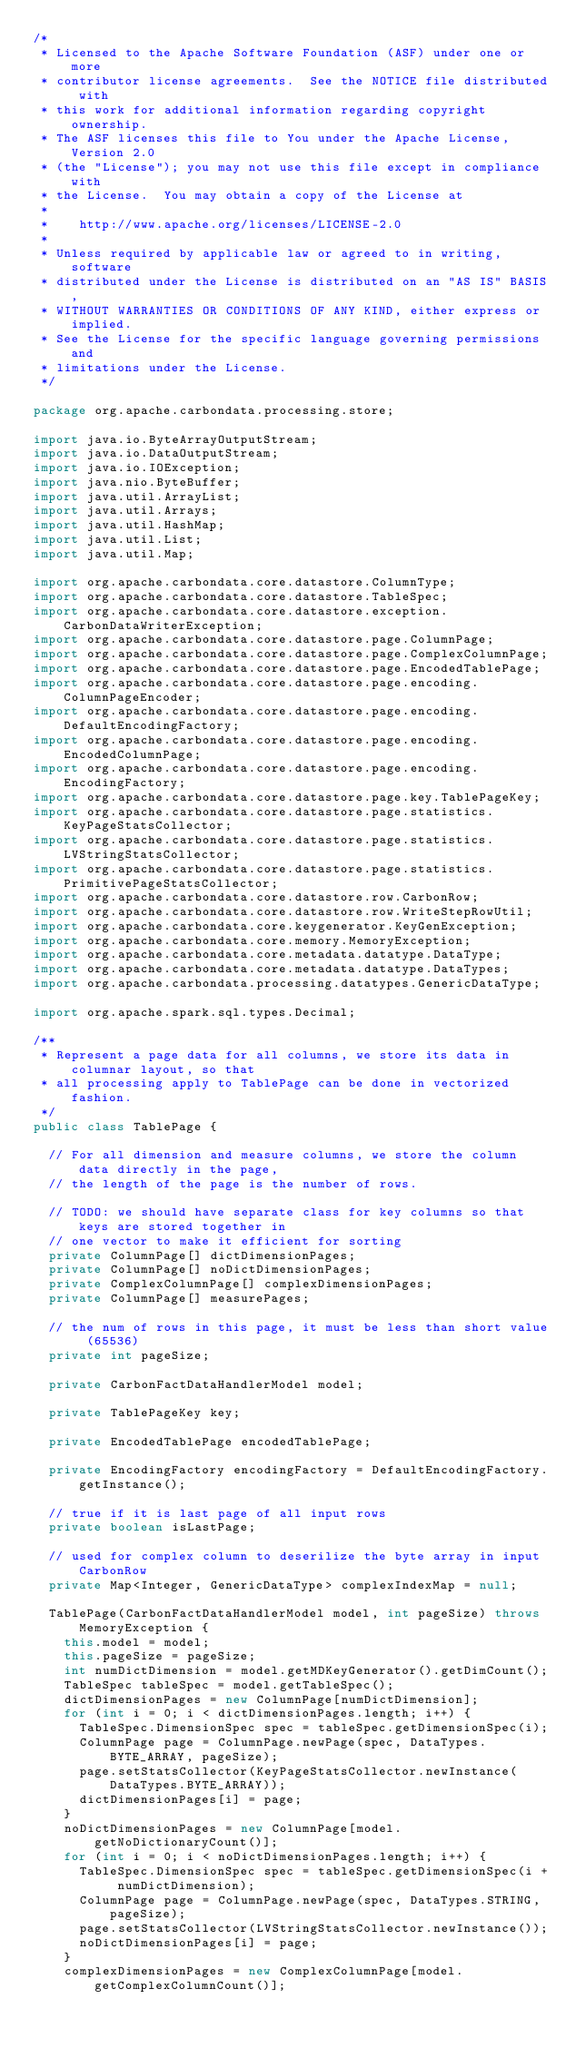<code> <loc_0><loc_0><loc_500><loc_500><_Java_>/*
 * Licensed to the Apache Software Foundation (ASF) under one or more
 * contributor license agreements.  See the NOTICE file distributed with
 * this work for additional information regarding copyright ownership.
 * The ASF licenses this file to You under the Apache License, Version 2.0
 * (the "License"); you may not use this file except in compliance with
 * the License.  You may obtain a copy of the License at
 *
 *    http://www.apache.org/licenses/LICENSE-2.0
 *
 * Unless required by applicable law or agreed to in writing, software
 * distributed under the License is distributed on an "AS IS" BASIS,
 * WITHOUT WARRANTIES OR CONDITIONS OF ANY KIND, either express or implied.
 * See the License for the specific language governing permissions and
 * limitations under the License.
 */

package org.apache.carbondata.processing.store;

import java.io.ByteArrayOutputStream;
import java.io.DataOutputStream;
import java.io.IOException;
import java.nio.ByteBuffer;
import java.util.ArrayList;
import java.util.Arrays;
import java.util.HashMap;
import java.util.List;
import java.util.Map;

import org.apache.carbondata.core.datastore.ColumnType;
import org.apache.carbondata.core.datastore.TableSpec;
import org.apache.carbondata.core.datastore.exception.CarbonDataWriterException;
import org.apache.carbondata.core.datastore.page.ColumnPage;
import org.apache.carbondata.core.datastore.page.ComplexColumnPage;
import org.apache.carbondata.core.datastore.page.EncodedTablePage;
import org.apache.carbondata.core.datastore.page.encoding.ColumnPageEncoder;
import org.apache.carbondata.core.datastore.page.encoding.DefaultEncodingFactory;
import org.apache.carbondata.core.datastore.page.encoding.EncodedColumnPage;
import org.apache.carbondata.core.datastore.page.encoding.EncodingFactory;
import org.apache.carbondata.core.datastore.page.key.TablePageKey;
import org.apache.carbondata.core.datastore.page.statistics.KeyPageStatsCollector;
import org.apache.carbondata.core.datastore.page.statistics.LVStringStatsCollector;
import org.apache.carbondata.core.datastore.page.statistics.PrimitivePageStatsCollector;
import org.apache.carbondata.core.datastore.row.CarbonRow;
import org.apache.carbondata.core.datastore.row.WriteStepRowUtil;
import org.apache.carbondata.core.keygenerator.KeyGenException;
import org.apache.carbondata.core.memory.MemoryException;
import org.apache.carbondata.core.metadata.datatype.DataType;
import org.apache.carbondata.core.metadata.datatype.DataTypes;
import org.apache.carbondata.processing.datatypes.GenericDataType;

import org.apache.spark.sql.types.Decimal;

/**
 * Represent a page data for all columns, we store its data in columnar layout, so that
 * all processing apply to TablePage can be done in vectorized fashion.
 */
public class TablePage {

  // For all dimension and measure columns, we store the column data directly in the page,
  // the length of the page is the number of rows.

  // TODO: we should have separate class for key columns so that keys are stored together in
  // one vector to make it efficient for sorting
  private ColumnPage[] dictDimensionPages;
  private ColumnPage[] noDictDimensionPages;
  private ComplexColumnPage[] complexDimensionPages;
  private ColumnPage[] measurePages;

  // the num of rows in this page, it must be less than short value (65536)
  private int pageSize;

  private CarbonFactDataHandlerModel model;

  private TablePageKey key;

  private EncodedTablePage encodedTablePage;

  private EncodingFactory encodingFactory = DefaultEncodingFactory.getInstance();

  // true if it is last page of all input rows
  private boolean isLastPage;

  // used for complex column to deserilize the byte array in input CarbonRow
  private Map<Integer, GenericDataType> complexIndexMap = null;

  TablePage(CarbonFactDataHandlerModel model, int pageSize) throws MemoryException {
    this.model = model;
    this.pageSize = pageSize;
    int numDictDimension = model.getMDKeyGenerator().getDimCount();
    TableSpec tableSpec = model.getTableSpec();
    dictDimensionPages = new ColumnPage[numDictDimension];
    for (int i = 0; i < dictDimensionPages.length; i++) {
      TableSpec.DimensionSpec spec = tableSpec.getDimensionSpec(i);
      ColumnPage page = ColumnPage.newPage(spec, DataTypes.BYTE_ARRAY, pageSize);
      page.setStatsCollector(KeyPageStatsCollector.newInstance(DataTypes.BYTE_ARRAY));
      dictDimensionPages[i] = page;
    }
    noDictDimensionPages = new ColumnPage[model.getNoDictionaryCount()];
    for (int i = 0; i < noDictDimensionPages.length; i++) {
      TableSpec.DimensionSpec spec = tableSpec.getDimensionSpec(i + numDictDimension);
      ColumnPage page = ColumnPage.newPage(spec, DataTypes.STRING, pageSize);
      page.setStatsCollector(LVStringStatsCollector.newInstance());
      noDictDimensionPages[i] = page;
    }
    complexDimensionPages = new ComplexColumnPage[model.getComplexColumnCount()];</code> 